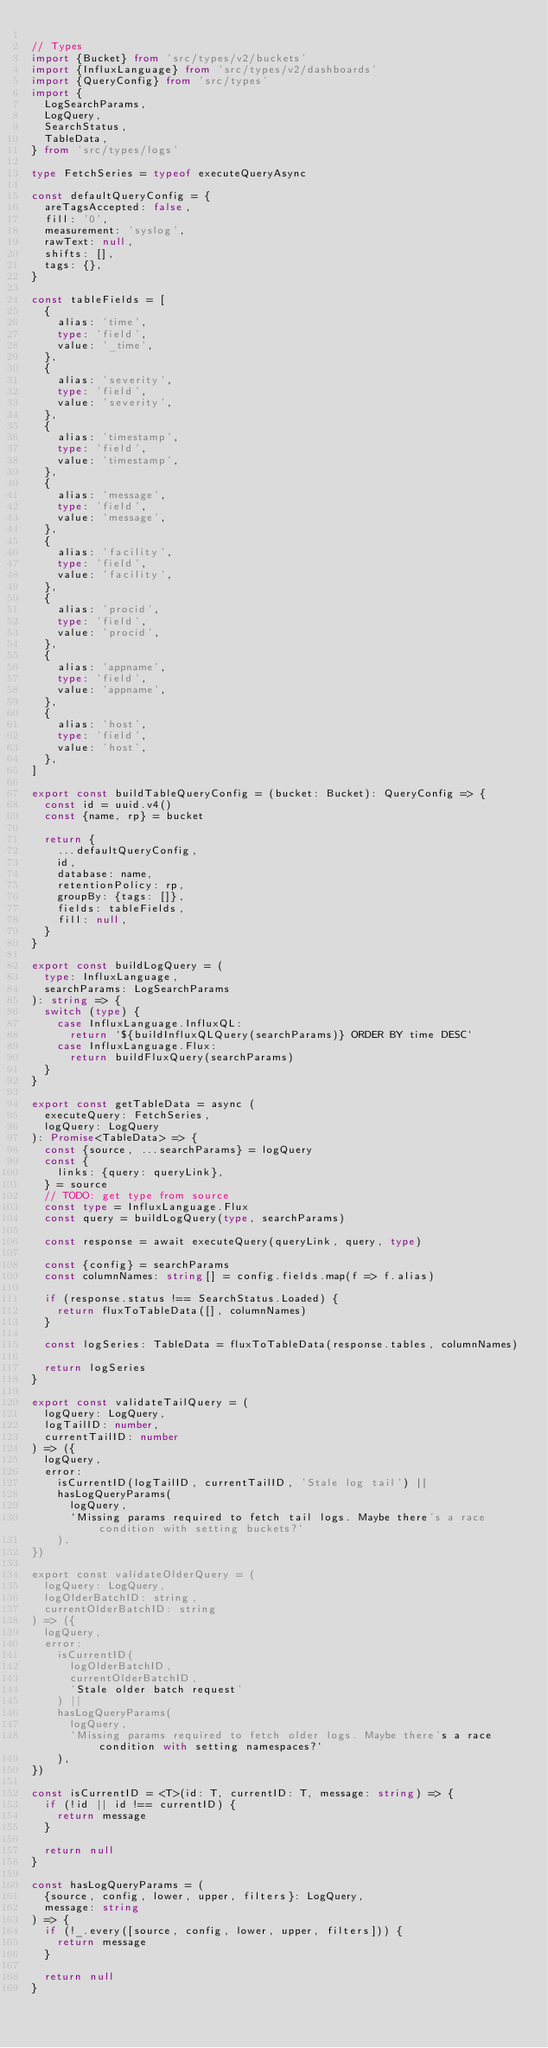<code> <loc_0><loc_0><loc_500><loc_500><_TypeScript_>
// Types
import {Bucket} from 'src/types/v2/buckets'
import {InfluxLanguage} from 'src/types/v2/dashboards'
import {QueryConfig} from 'src/types'
import {
  LogSearchParams,
  LogQuery,
  SearchStatus,
  TableData,
} from 'src/types/logs'

type FetchSeries = typeof executeQueryAsync

const defaultQueryConfig = {
  areTagsAccepted: false,
  fill: '0',
  measurement: 'syslog',
  rawText: null,
  shifts: [],
  tags: {},
}

const tableFields = [
  {
    alias: 'time',
    type: 'field',
    value: '_time',
  },
  {
    alias: 'severity',
    type: 'field',
    value: 'severity',
  },
  {
    alias: 'timestamp',
    type: 'field',
    value: 'timestamp',
  },
  {
    alias: 'message',
    type: 'field',
    value: 'message',
  },
  {
    alias: 'facility',
    type: 'field',
    value: 'facility',
  },
  {
    alias: 'procid',
    type: 'field',
    value: 'procid',
  },
  {
    alias: 'appname',
    type: 'field',
    value: 'appname',
  },
  {
    alias: 'host',
    type: 'field',
    value: 'host',
  },
]

export const buildTableQueryConfig = (bucket: Bucket): QueryConfig => {
  const id = uuid.v4()
  const {name, rp} = bucket

  return {
    ...defaultQueryConfig,
    id,
    database: name,
    retentionPolicy: rp,
    groupBy: {tags: []},
    fields: tableFields,
    fill: null,
  }
}

export const buildLogQuery = (
  type: InfluxLanguage,
  searchParams: LogSearchParams
): string => {
  switch (type) {
    case InfluxLanguage.InfluxQL:
      return `${buildInfluxQLQuery(searchParams)} ORDER BY time DESC`
    case InfluxLanguage.Flux:
      return buildFluxQuery(searchParams)
  }
}

export const getTableData = async (
  executeQuery: FetchSeries,
  logQuery: LogQuery
): Promise<TableData> => {
  const {source, ...searchParams} = logQuery
  const {
    links: {query: queryLink},
  } = source
  // TODO: get type from source
  const type = InfluxLanguage.Flux
  const query = buildLogQuery(type, searchParams)

  const response = await executeQuery(queryLink, query, type)

  const {config} = searchParams
  const columnNames: string[] = config.fields.map(f => f.alias)

  if (response.status !== SearchStatus.Loaded) {
    return fluxToTableData([], columnNames)
  }

  const logSeries: TableData = fluxToTableData(response.tables, columnNames)

  return logSeries
}

export const validateTailQuery = (
  logQuery: LogQuery,
  logTailID: number,
  currentTailID: number
) => ({
  logQuery,
  error:
    isCurrentID(logTailID, currentTailID, 'Stale log tail') ||
    hasLogQueryParams(
      logQuery,
      `Missing params required to fetch tail logs. Maybe there's a race condition with setting buckets?`
    ),
})

export const validateOlderQuery = (
  logQuery: LogQuery,
  logOlderBatchID: string,
  currentOlderBatchID: string
) => ({
  logQuery,
  error:
    isCurrentID(
      logOlderBatchID,
      currentOlderBatchID,
      'Stale older batch request'
    ) ||
    hasLogQueryParams(
      logQuery,
      `Missing params required to fetch older logs. Maybe there's a race condition with setting namespaces?`
    ),
})

const isCurrentID = <T>(id: T, currentID: T, message: string) => {
  if (!id || id !== currentID) {
    return message
  }

  return null
}

const hasLogQueryParams = (
  {source, config, lower, upper, filters}: LogQuery,
  message: string
) => {
  if (!_.every([source, config, lower, upper, filters])) {
    return message
  }

  return null
}
</code> 